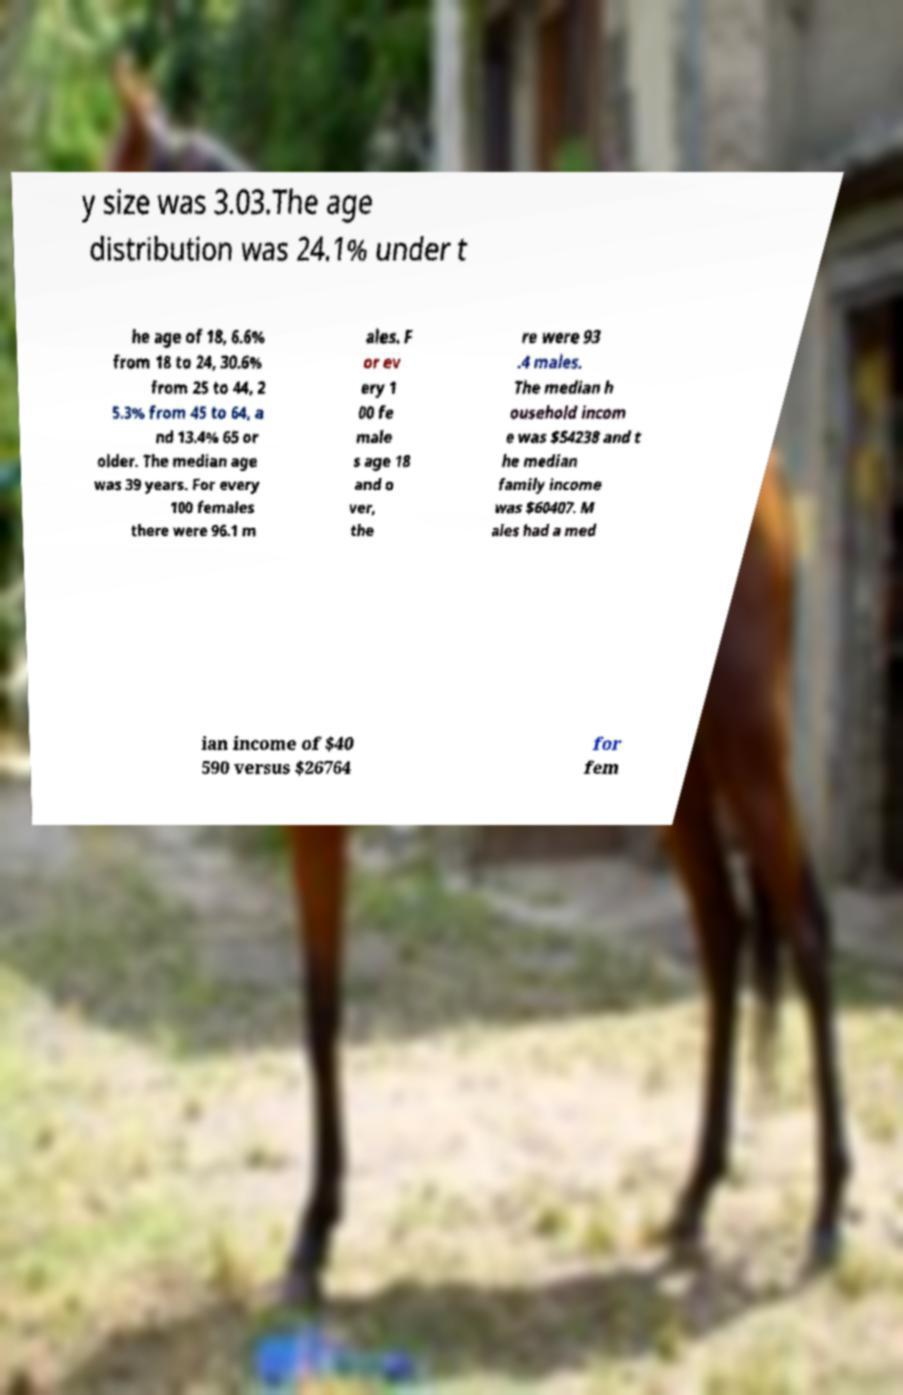There's text embedded in this image that I need extracted. Can you transcribe it verbatim? y size was 3.03.The age distribution was 24.1% under t he age of 18, 6.6% from 18 to 24, 30.6% from 25 to 44, 2 5.3% from 45 to 64, a nd 13.4% 65 or older. The median age was 39 years. For every 100 females there were 96.1 m ales. F or ev ery 1 00 fe male s age 18 and o ver, the re were 93 .4 males. The median h ousehold incom e was $54238 and t he median family income was $60407. M ales had a med ian income of $40 590 versus $26764 for fem 